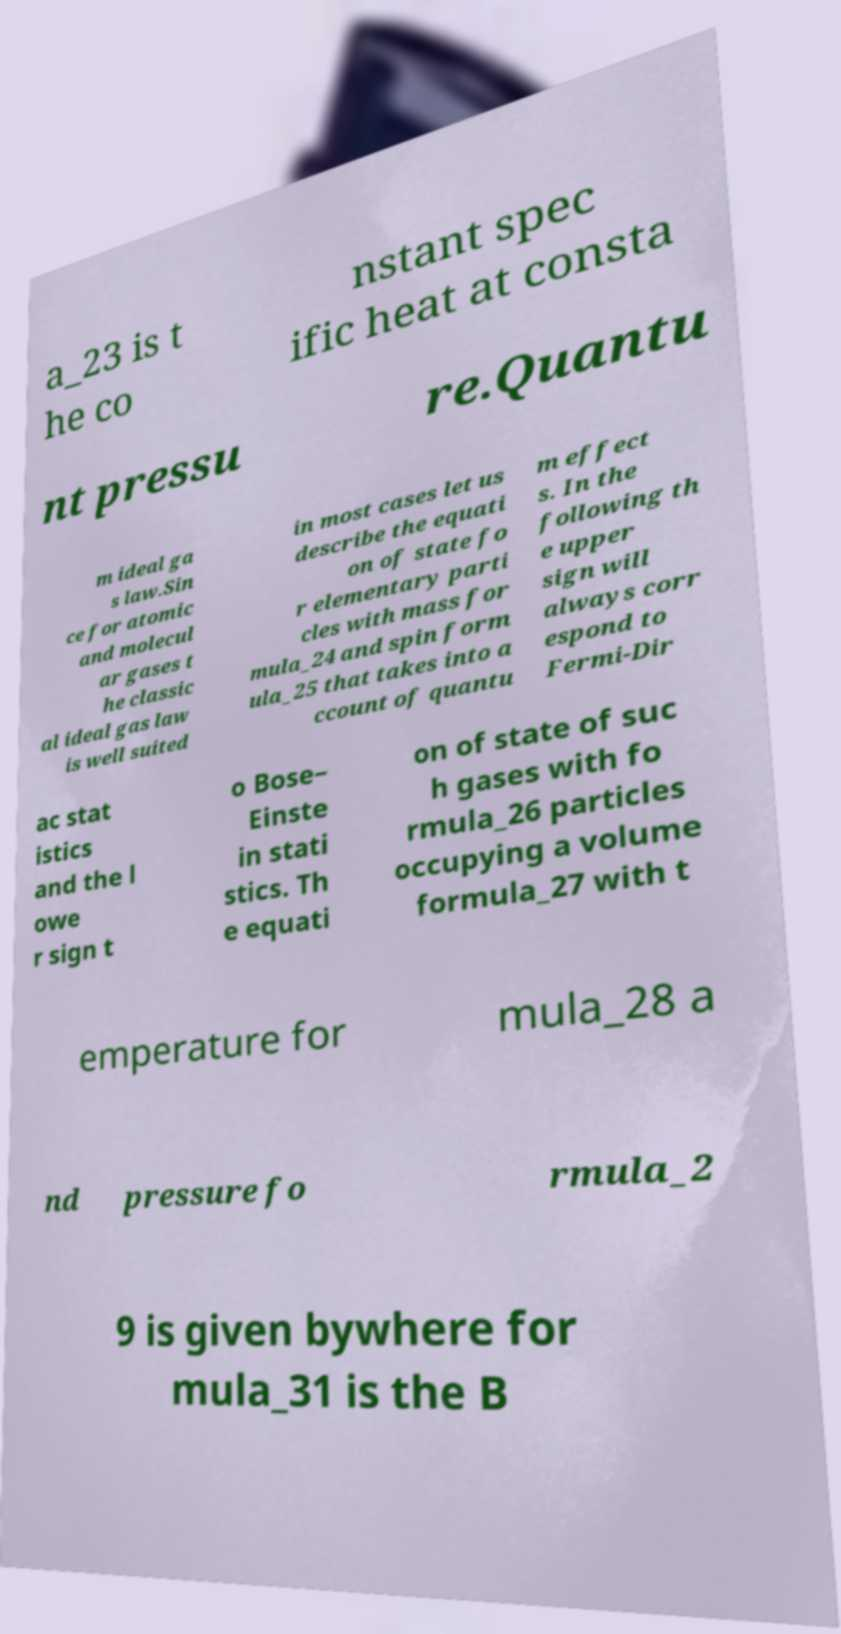For documentation purposes, I need the text within this image transcribed. Could you provide that? a_23 is t he co nstant spec ific heat at consta nt pressu re.Quantu m ideal ga s law.Sin ce for atomic and molecul ar gases t he classic al ideal gas law is well suited in most cases let us describe the equati on of state fo r elementary parti cles with mass for mula_24 and spin form ula_25 that takes into a ccount of quantu m effect s. In the following th e upper sign will always corr espond to Fermi-Dir ac stat istics and the l owe r sign t o Bose– Einste in stati stics. Th e equati on of state of suc h gases with fo rmula_26 particles occupying a volume formula_27 with t emperature for mula_28 a nd pressure fo rmula_2 9 is given bywhere for mula_31 is the B 